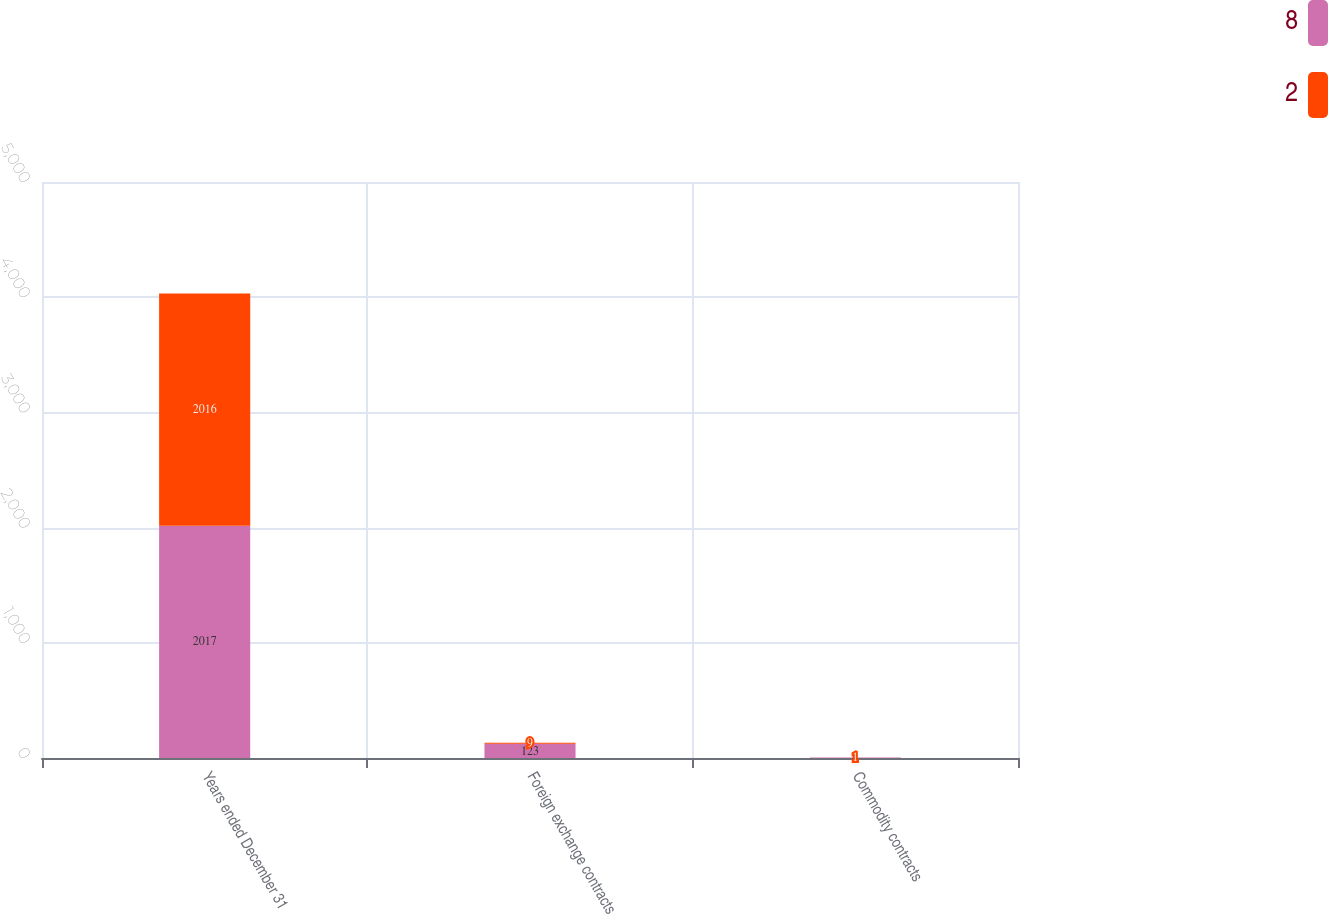Convert chart. <chart><loc_0><loc_0><loc_500><loc_500><stacked_bar_chart><ecel><fcel>Years ended December 31<fcel>Foreign exchange contracts<fcel>Commodity contracts<nl><fcel>8<fcel>2017<fcel>123<fcel>4<nl><fcel>2<fcel>2016<fcel>9<fcel>1<nl></chart> 